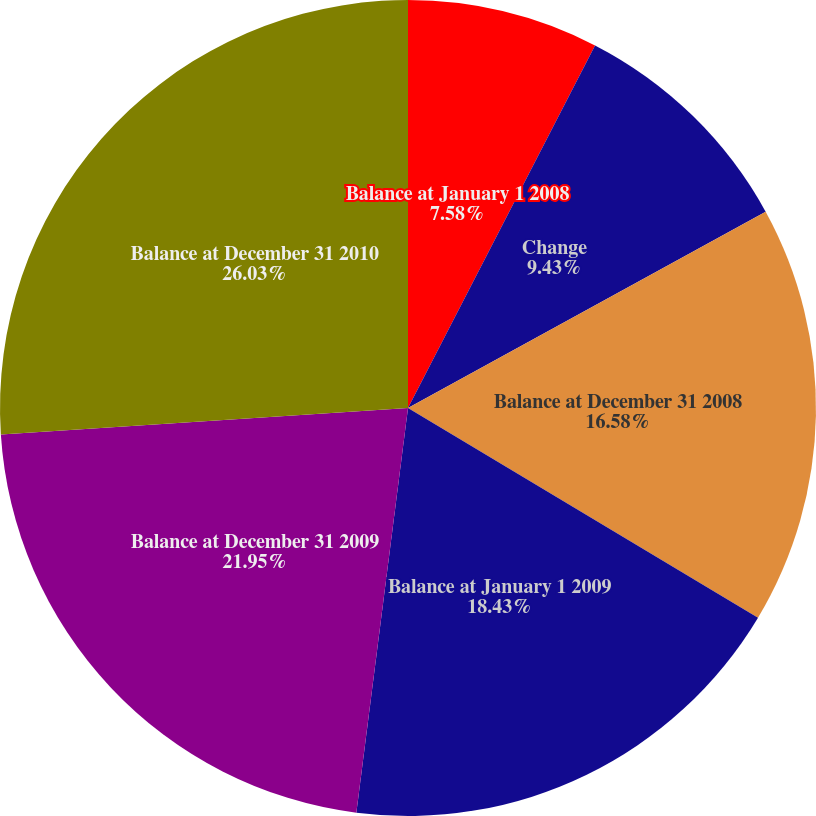Convert chart. <chart><loc_0><loc_0><loc_500><loc_500><pie_chart><fcel>Balance at January 1 2008<fcel>Change<fcel>Balance at December 31 2008<fcel>Balance at January 1 2009<fcel>Balance at December 31 2009<fcel>Balance at December 31 2010<nl><fcel>7.58%<fcel>9.43%<fcel>16.58%<fcel>18.43%<fcel>21.95%<fcel>26.03%<nl></chart> 